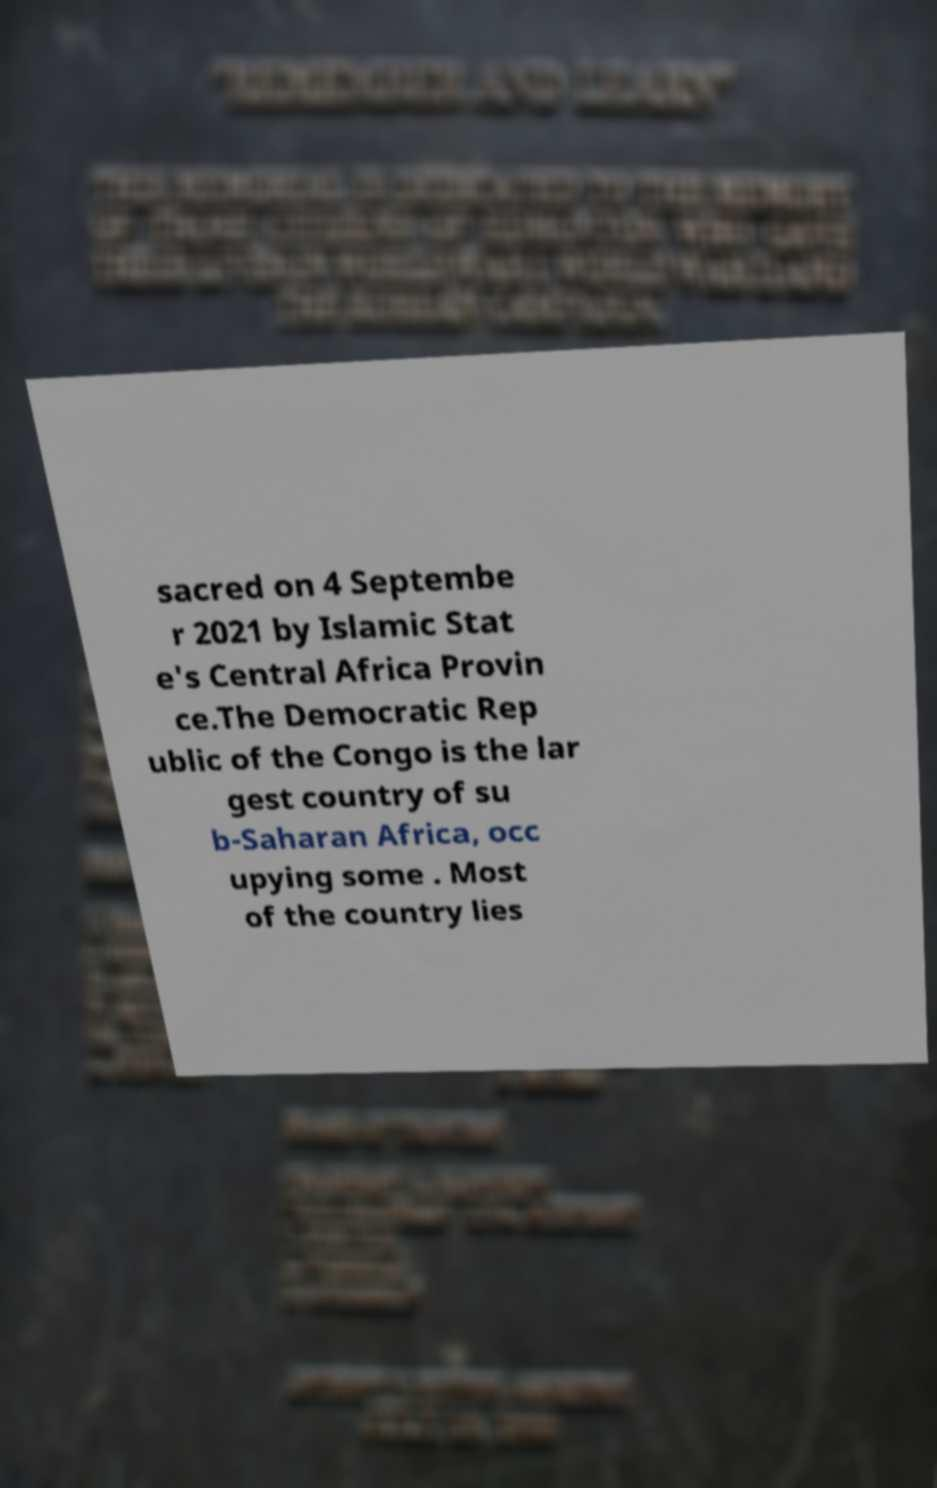Please read and relay the text visible in this image. What does it say? sacred on 4 Septembe r 2021 by Islamic Stat e's Central Africa Provin ce.The Democratic Rep ublic of the Congo is the lar gest country of su b-Saharan Africa, occ upying some . Most of the country lies 